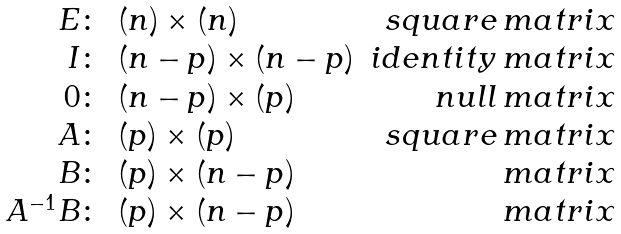<formula> <loc_0><loc_0><loc_500><loc_500>\begin{array} { r l r } E \colon & ( n ) \times ( n ) & s q u a r e \, m a t r i x \\ I \colon & ( n - p ) \times ( n - p ) & i d e n t i t y \, m a t r i x \\ 0 \colon & ( n - p ) \times ( p ) & n u l l \, m a t r i x \\ A \colon & ( p ) \times ( p ) & s q u a r e \, m a t r i x \\ B \colon & ( p ) \times ( n - p ) & \, m a t r i x \\ A ^ { - 1 } B \colon & ( p ) \times ( n - p ) & \, m a t r i x \end{array}</formula> 